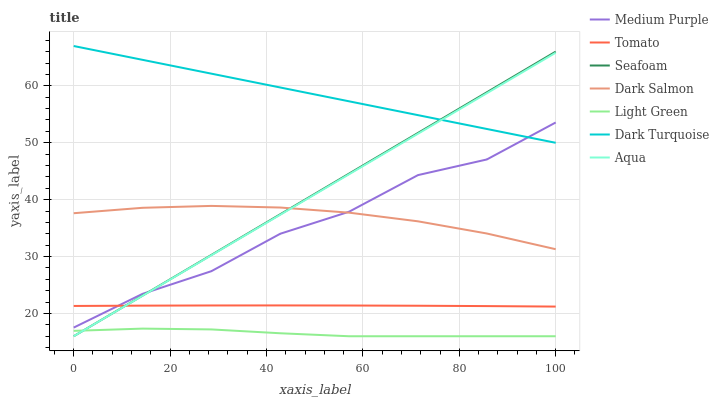Does Light Green have the minimum area under the curve?
Answer yes or no. Yes. Does Dark Turquoise have the maximum area under the curve?
Answer yes or no. Yes. Does Aqua have the minimum area under the curve?
Answer yes or no. No. Does Aqua have the maximum area under the curve?
Answer yes or no. No. Is Aqua the smoothest?
Answer yes or no. Yes. Is Medium Purple the roughest?
Answer yes or no. Yes. Is Dark Turquoise the smoothest?
Answer yes or no. No. Is Dark Turquoise the roughest?
Answer yes or no. No. Does Aqua have the lowest value?
Answer yes or no. Yes. Does Dark Turquoise have the lowest value?
Answer yes or no. No. Does Dark Turquoise have the highest value?
Answer yes or no. Yes. Does Aqua have the highest value?
Answer yes or no. No. Is Light Green less than Dark Salmon?
Answer yes or no. Yes. Is Dark Salmon greater than Tomato?
Answer yes or no. Yes. Does Seafoam intersect Light Green?
Answer yes or no. Yes. Is Seafoam less than Light Green?
Answer yes or no. No. Is Seafoam greater than Light Green?
Answer yes or no. No. Does Light Green intersect Dark Salmon?
Answer yes or no. No. 